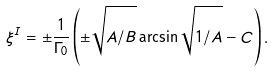<formula> <loc_0><loc_0><loc_500><loc_500>\xi ^ { I } = \pm \frac { 1 } { \Gamma _ { 0 } } \left ( \pm \sqrt { \strut { A / B } } \arcsin \sqrt { \strut { 1 / A } } - C \right ) .</formula> 